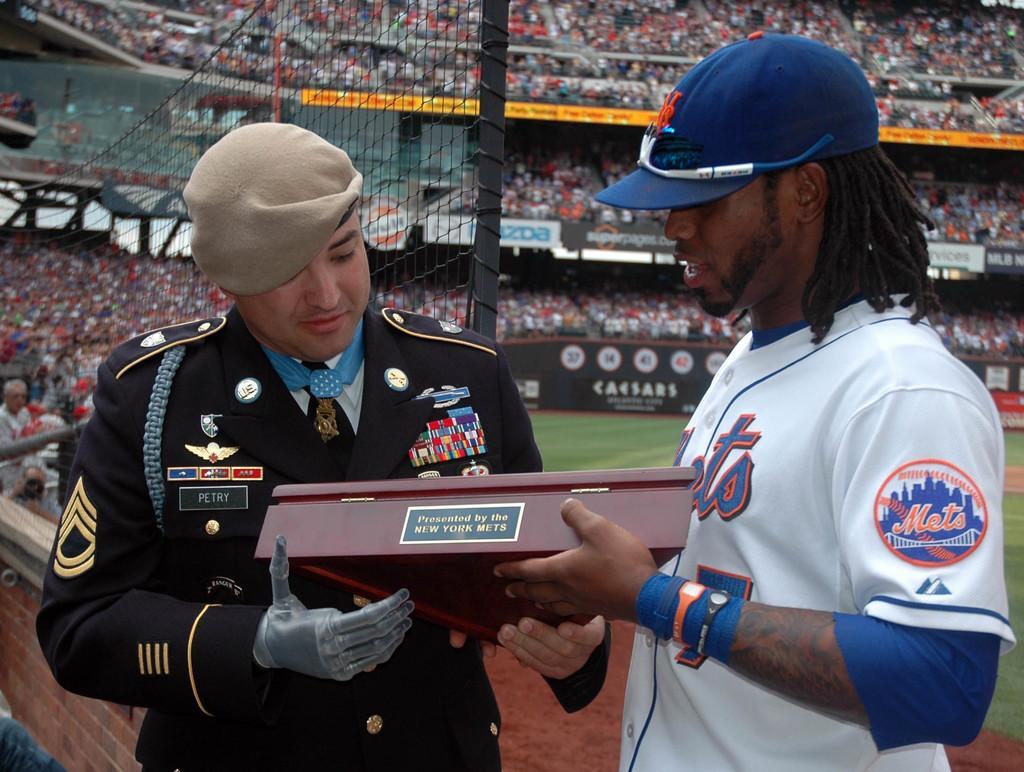In one or two sentences, can you explain what this image depicts? In this image there are two persons are standing and holding an object as we can see in middle of this image. The right side person is wearing white color t shirt and blue color cap and the left side person is wearing black color dress,and there is a boundary wall in middle of this image and there are some audience are sitting at outside to this boundary wall. 